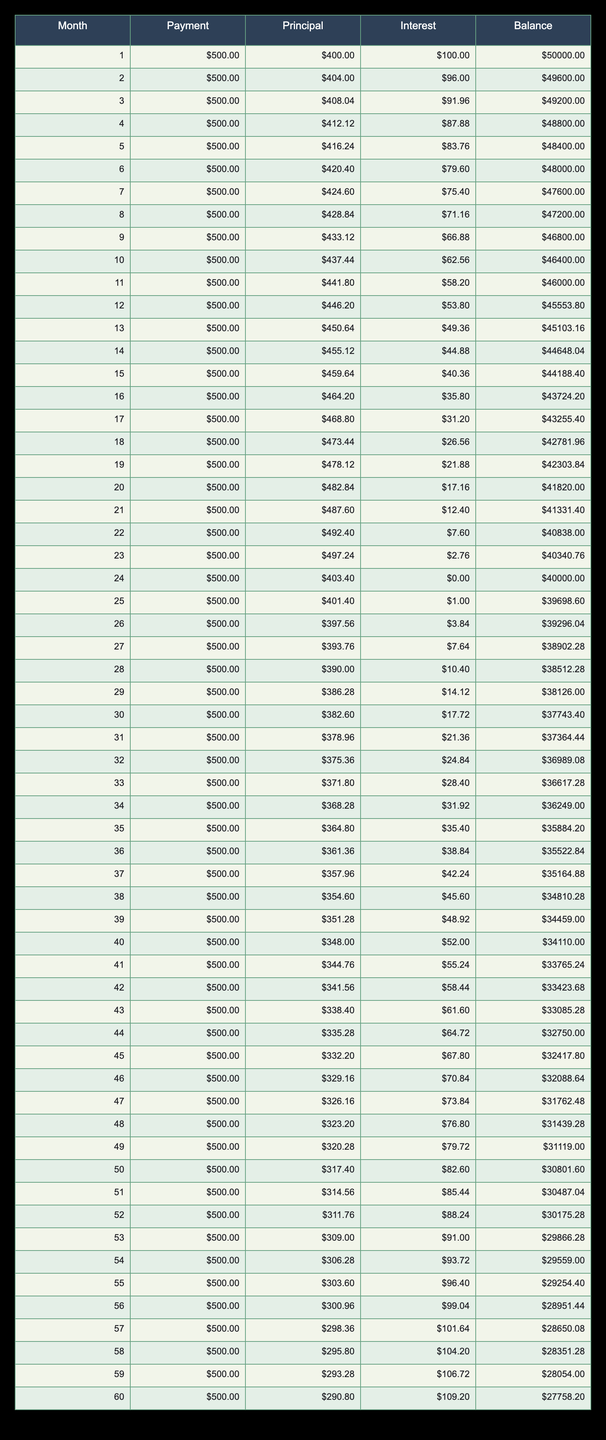What is the total payment made after the 12th month? To find the total payment made after the 12th month, we need to multiply the monthly payment by the number of months. The monthly payment is 500.00, and after 12 months, the total is 500.00 * 12 = 6000.00.
Answer: 6000.00 What is the balance remaining after 24 months? The balance remaining after 24 months can be found directly from the table's balance column. After 24 months, the balance is listed as 40000.00.
Answer: 40000.00 Is the interest payment in the first month higher than the interest payment in the last month? In the first month, the interest payment is 100.00, and in the last month (the 60th month), it is 109.20. Since 100.00 is less than 109.20, the statement is false.
Answer: No How much principal is paid off during the last three months (months 58, 59, and 60)? To calculate the total principal paid during the last three months, we need to sum the principal values for those months: 295.80 + 293.28 + 290.80 = 879.88.
Answer: 879.88 What is the average monthly payment over the 60-month period? The monthly payment remains constant at 500.00 for all months, so the average is the same as the monthly payment: 500.00.
Answer: 500.00 Was the principal payment in month 30 higher than the principal payment in month 15? In month 30, the principal payment is 382.60, while in month 15 it is 459.64. Since 382.60 is less than 459.64, the statement is false.
Answer: No What is the total interest paid over the first 6 months? We need to sum the interest payments for the first 6 months: 100.00 + 96.00 + 91.96 + 87.88 + 83.76 + 79.60 = 539.20.
Answer: 539.20 How does the interest payment change from month 1 to month 12? The interest payment decreases from month 1 (100.00) to month 12 (53.80). This shows a decrease in interest while the principal payment increases as the balance decreases, reflecting effective loan repayment.
Answer: Decreases In which month is the principal payment exactly 400.00? Looking through the principal column, the principal payment is exactly 400.00 in the first month (month 1).
Answer: Month 1 